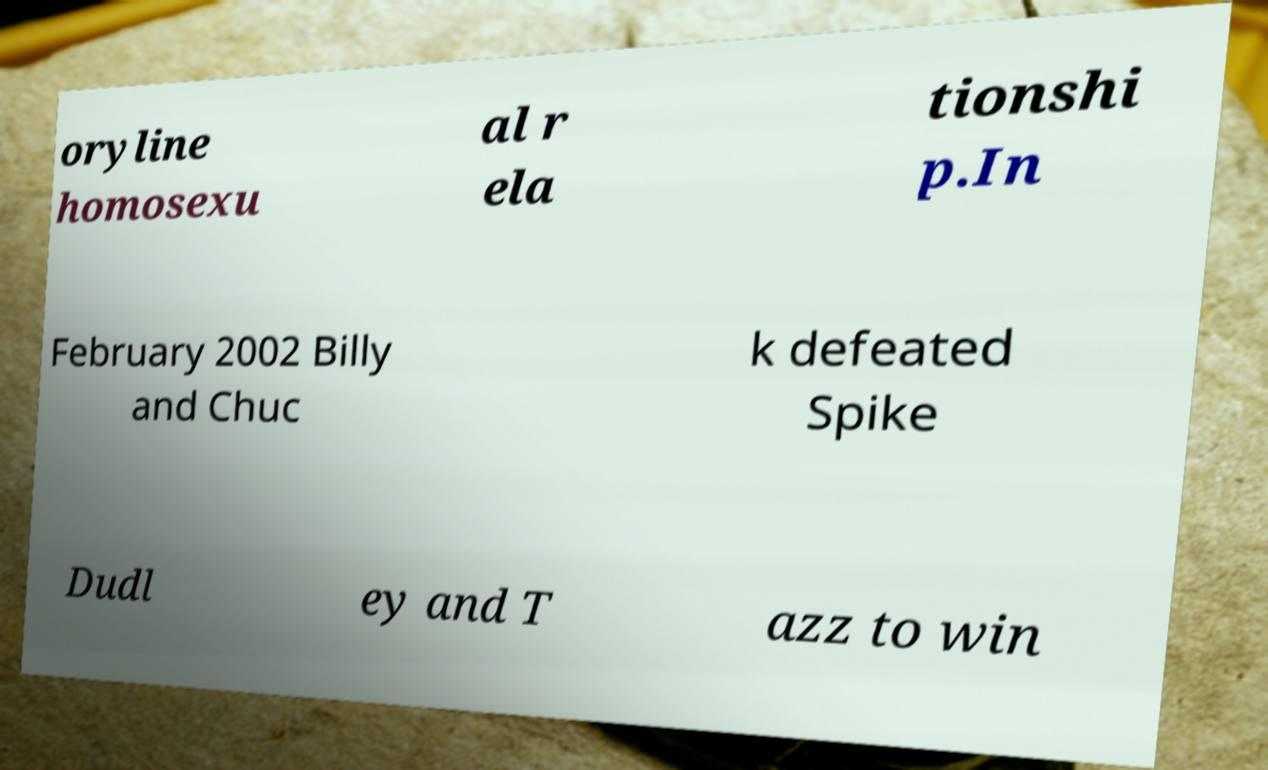Can you accurately transcribe the text from the provided image for me? oryline homosexu al r ela tionshi p.In February 2002 Billy and Chuc k defeated Spike Dudl ey and T azz to win 